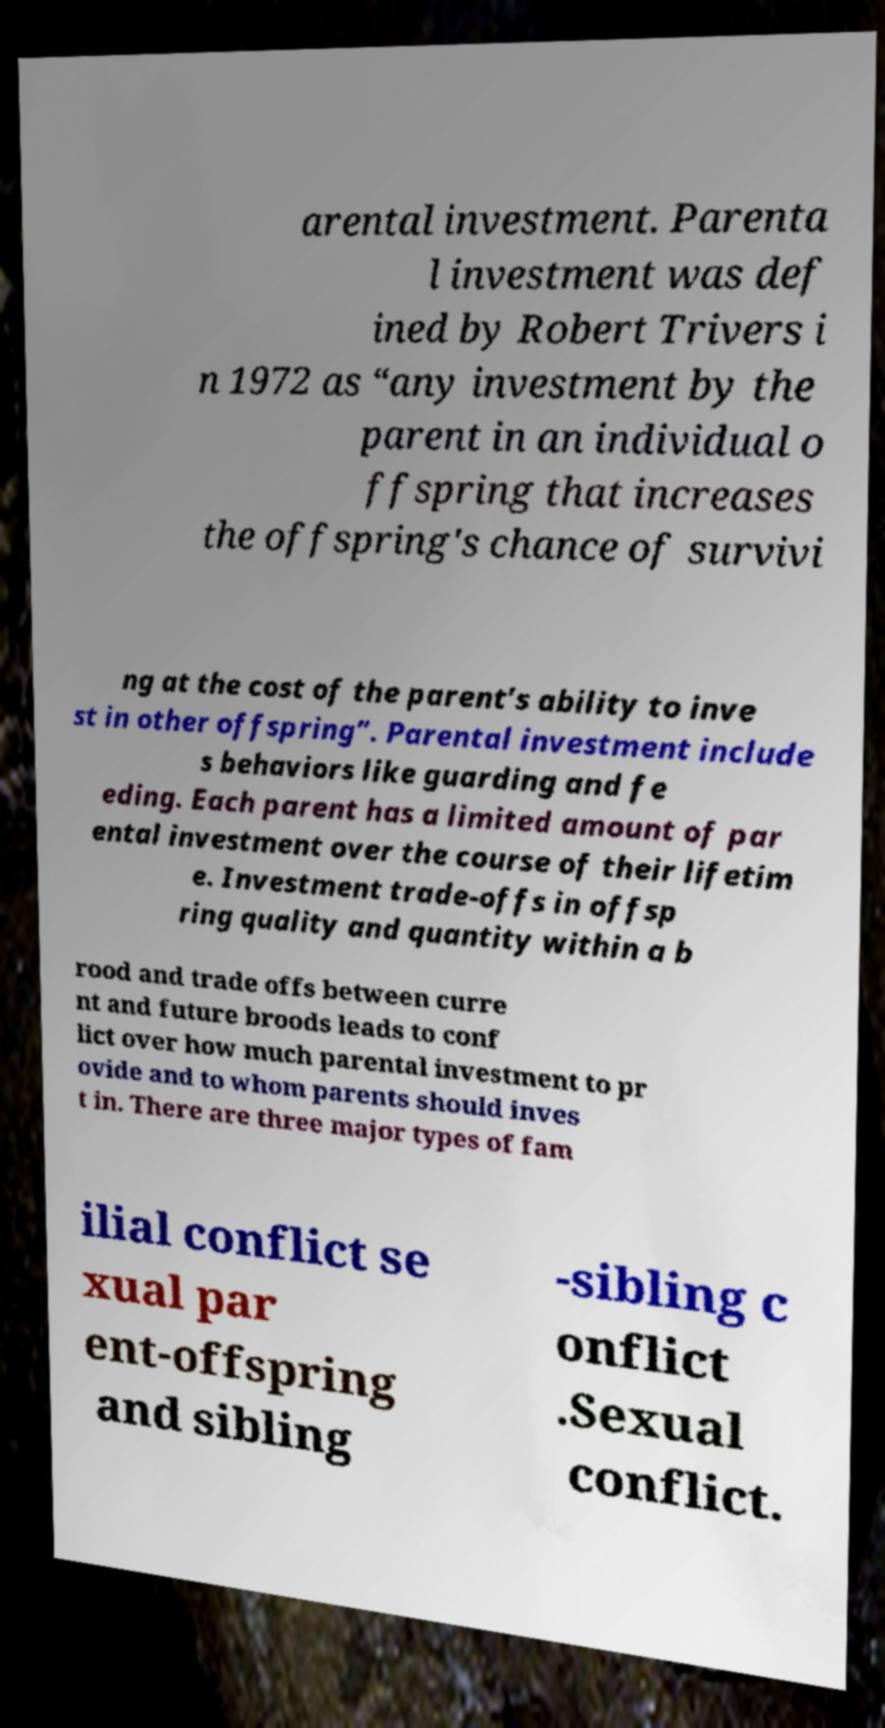I need the written content from this picture converted into text. Can you do that? arental investment. Parenta l investment was def ined by Robert Trivers i n 1972 as “any investment by the parent in an individual o ffspring that increases the offspring's chance of survivi ng at the cost of the parent’s ability to inve st in other offspring”. Parental investment include s behaviors like guarding and fe eding. Each parent has a limited amount of par ental investment over the course of their lifetim e. Investment trade-offs in offsp ring quality and quantity within a b rood and trade offs between curre nt and future broods leads to conf lict over how much parental investment to pr ovide and to whom parents should inves t in. There are three major types of fam ilial conflict se xual par ent-offspring and sibling -sibling c onflict .Sexual conflict. 